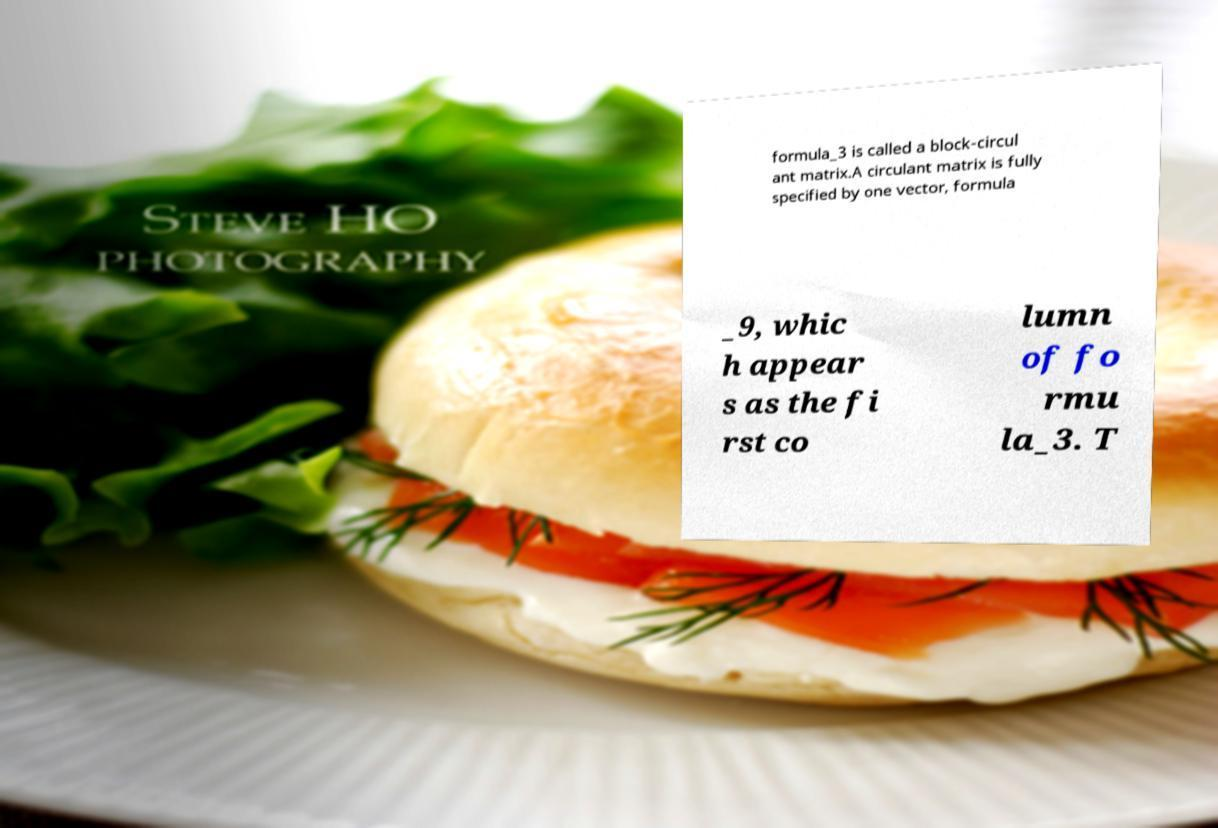Please read and relay the text visible in this image. What does it say? formula_3 is called a block-circul ant matrix.A circulant matrix is fully specified by one vector, formula _9, whic h appear s as the fi rst co lumn of fo rmu la_3. T 